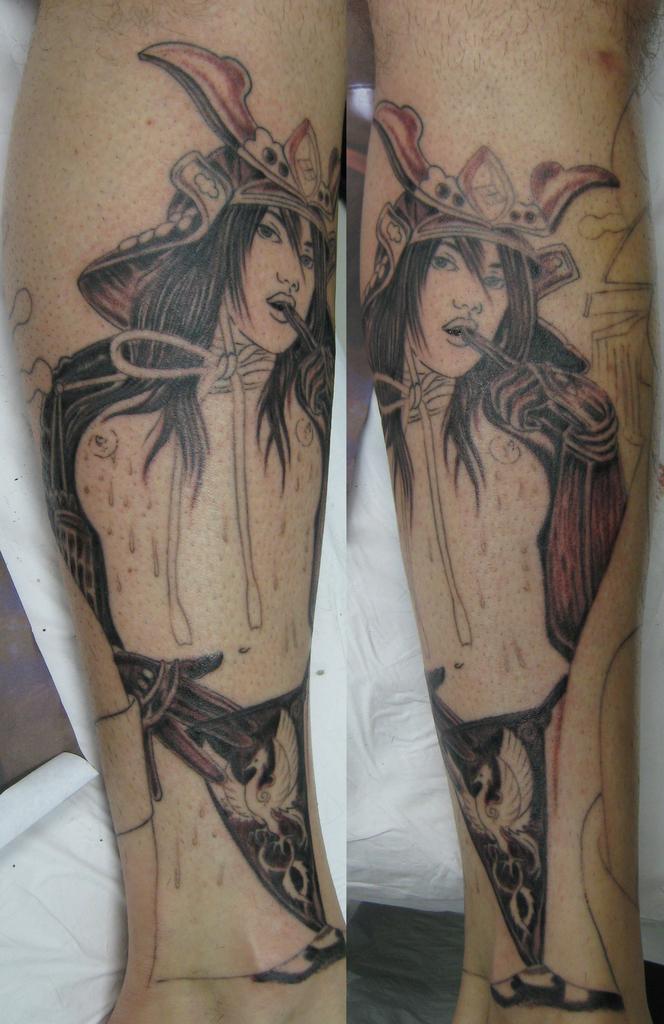Can you describe this image briefly? In this image I can see the legs and there is a art of person on the legs. In the back I can see the white cloth. 